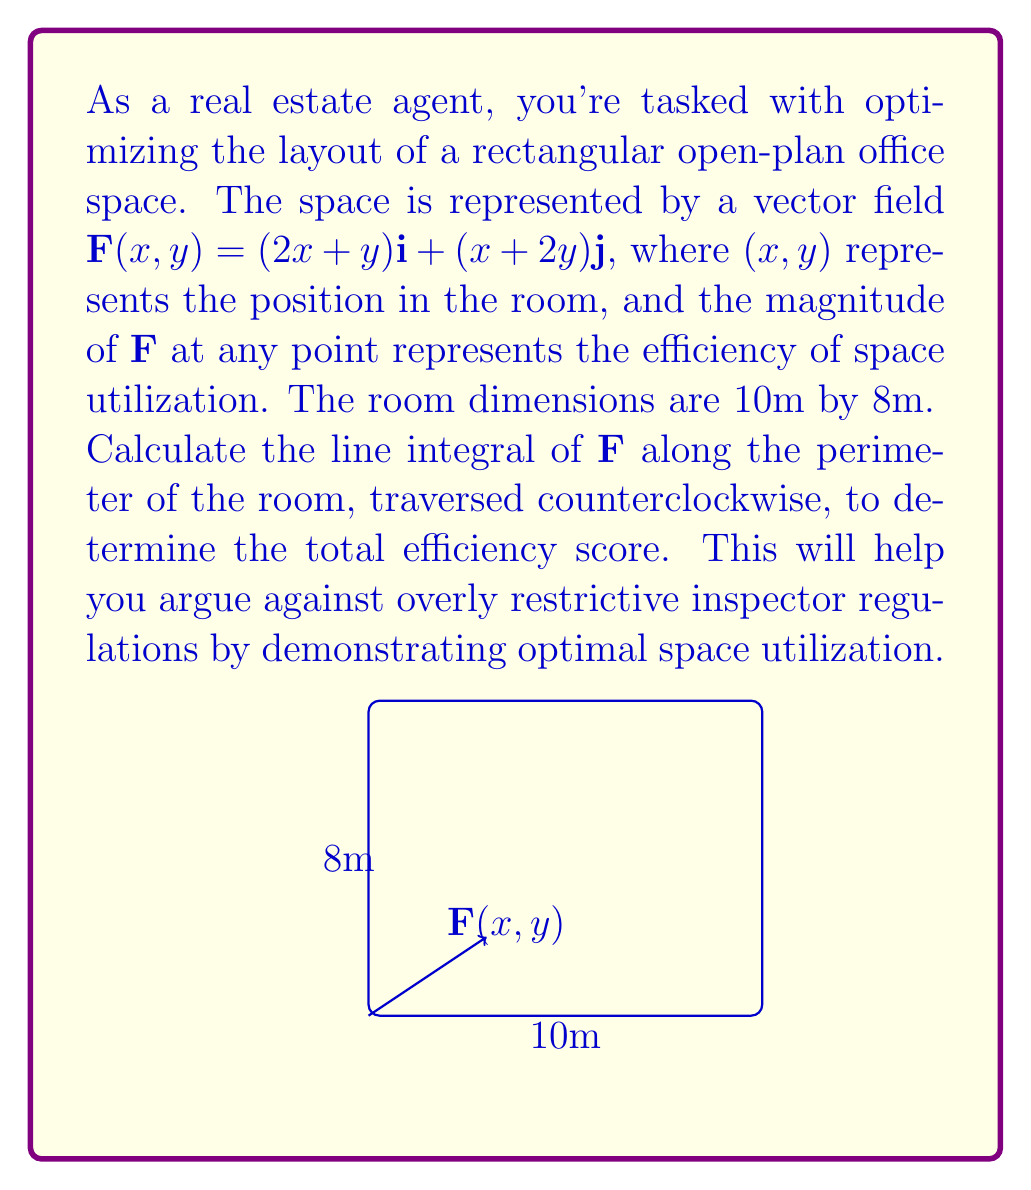Solve this math problem. To solve this problem, we'll use the line integral formula for a vector field:

$$\oint_C \mathbf{F} \cdot d\mathbf{r} = \oint_C (Pdx + Qdy)$$

Where $P = 2x+y$ and $Q = x+2y$.

We'll parameterize each side of the rectangle:

1) Bottom: $r_1(t) = (t,0)$, $0 \leq t \leq 10$
2) Right: $r_2(t) = (10,t)$, $0 \leq t \leq 8$
3) Top: $r_3(t) = (10-t,8)$, $0 \leq t \leq 10$
4) Left: $r_4(t) = (0,8-t)$, $0 \leq t \leq 8$

Now, let's calculate the line integral for each side:

1) Bottom: 
   $$\int_0^{10} (2t+0)dt = [t^2]_0^{10} = 100$$

2) Right:
   $$\int_0^8 (10+2t)dt = [10t+t^2]_0^8 = 144$$

3) Top:
   $$\int_0^{10} -(2(10-t)+8)dt = [-(20-2t)t-8t]_0^{10} = 100$$

4) Left:
   $$\int_0^8 -(0+(8-t))dt = [-8t+\frac{1}{2}t^2]_0^8 = -32$$

The total line integral is the sum of these four integrals:

$$100 + 144 + 100 - 32 = 312$$

This value represents the total efficiency score for the office layout.
Answer: 312 